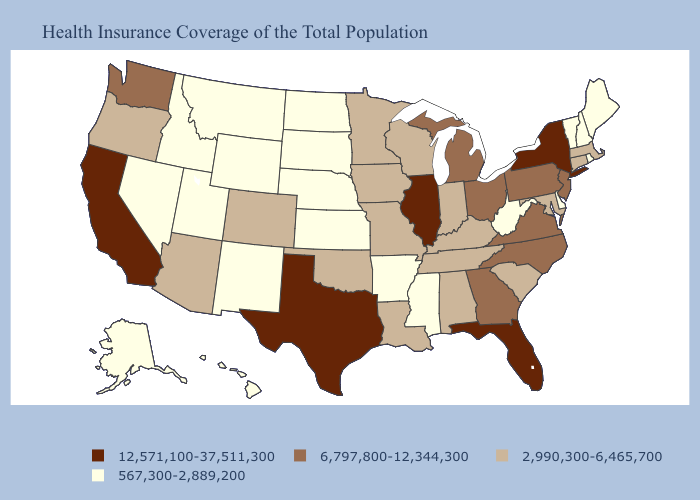What is the highest value in the USA?
Keep it brief. 12,571,100-37,511,300. Does Minnesota have the same value as Utah?
Keep it brief. No. Name the states that have a value in the range 12,571,100-37,511,300?
Give a very brief answer. California, Florida, Illinois, New York, Texas. How many symbols are there in the legend?
Concise answer only. 4. Which states have the highest value in the USA?
Keep it brief. California, Florida, Illinois, New York, Texas. What is the highest value in the Northeast ?
Answer briefly. 12,571,100-37,511,300. Name the states that have a value in the range 567,300-2,889,200?
Answer briefly. Alaska, Arkansas, Delaware, Hawaii, Idaho, Kansas, Maine, Mississippi, Montana, Nebraska, Nevada, New Hampshire, New Mexico, North Dakota, Rhode Island, South Dakota, Utah, Vermont, West Virginia, Wyoming. What is the lowest value in the USA?
Give a very brief answer. 567,300-2,889,200. Does Delaware have a lower value than Kentucky?
Answer briefly. Yes. Name the states that have a value in the range 567,300-2,889,200?
Short answer required. Alaska, Arkansas, Delaware, Hawaii, Idaho, Kansas, Maine, Mississippi, Montana, Nebraska, Nevada, New Hampshire, New Mexico, North Dakota, Rhode Island, South Dakota, Utah, Vermont, West Virginia, Wyoming. Name the states that have a value in the range 6,797,800-12,344,300?
Keep it brief. Georgia, Michigan, New Jersey, North Carolina, Ohio, Pennsylvania, Virginia, Washington. Does Illinois have the highest value in the MidWest?
Concise answer only. Yes. What is the value of North Carolina?
Keep it brief. 6,797,800-12,344,300. Among the states that border Idaho , does Washington have the highest value?
Be succinct. Yes. Among the states that border Colorado , which have the lowest value?
Answer briefly. Kansas, Nebraska, New Mexico, Utah, Wyoming. 